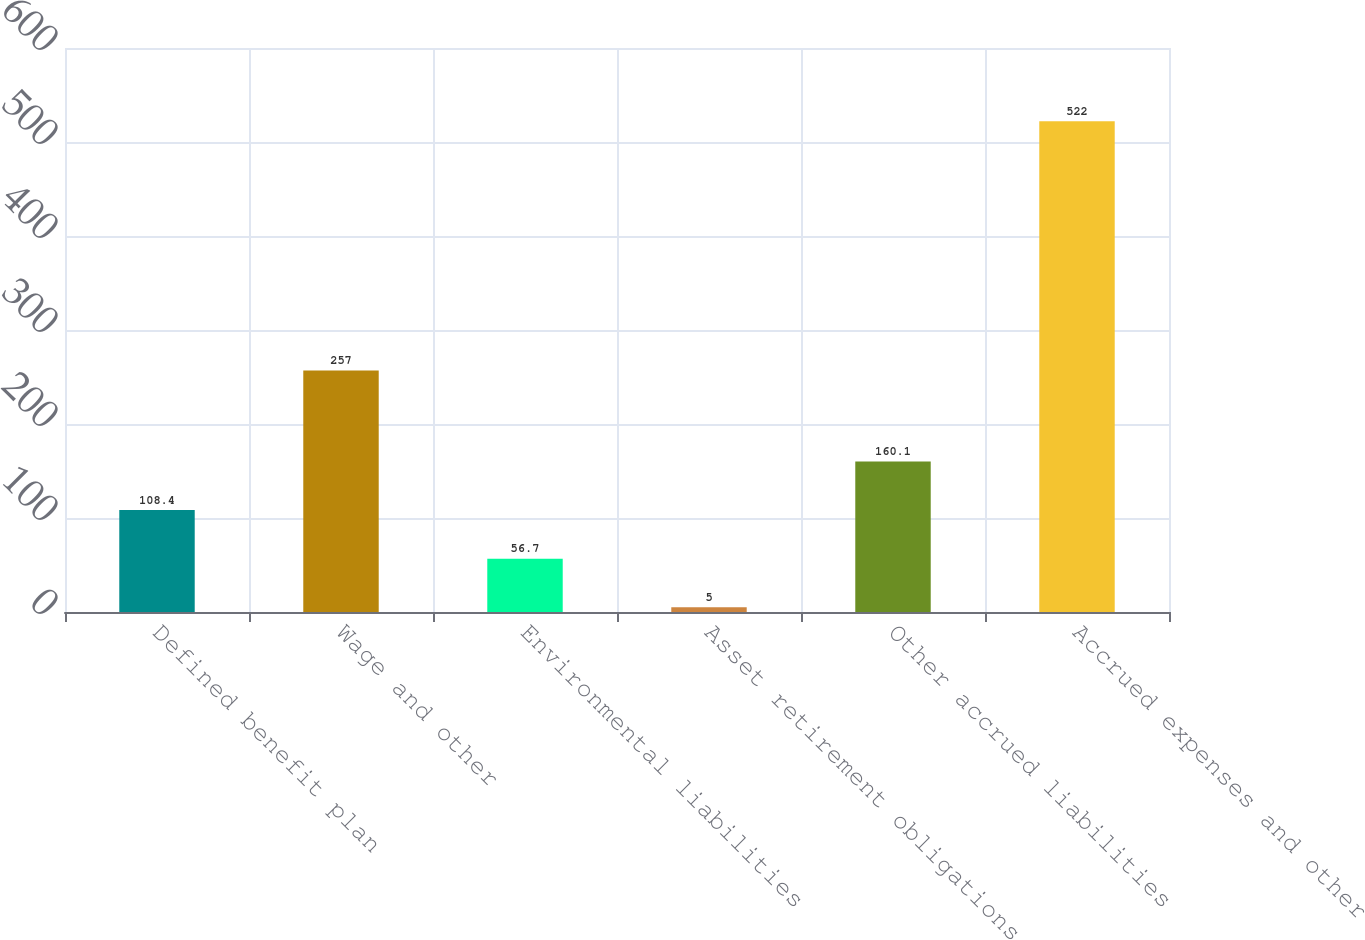<chart> <loc_0><loc_0><loc_500><loc_500><bar_chart><fcel>Defined benefit plan<fcel>Wage and other<fcel>Environmental liabilities<fcel>Asset retirement obligations<fcel>Other accrued liabilities<fcel>Accrued expenses and other<nl><fcel>108.4<fcel>257<fcel>56.7<fcel>5<fcel>160.1<fcel>522<nl></chart> 